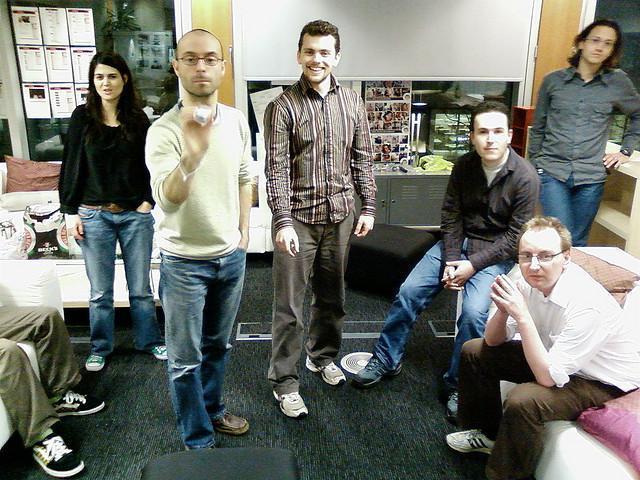Where is the group focusing their attention?
Indicate the correct response by choosing from the four available options to answer the question.
Options: Poster, screen, speaker, performer. Screen. 